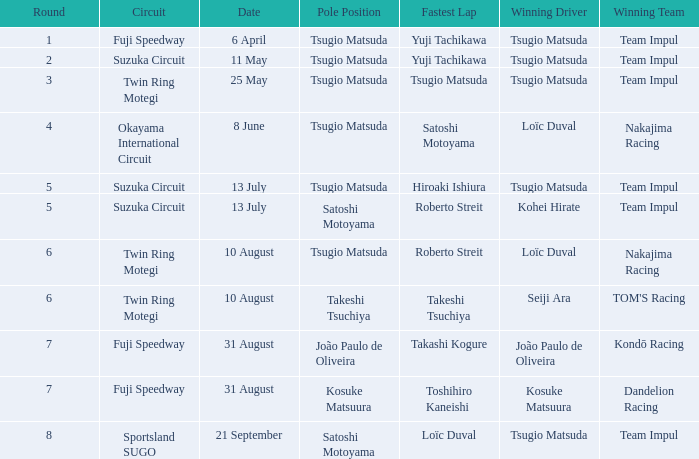On what day does yuji tachikawa record the fastest lap in round 1? 6 April. 